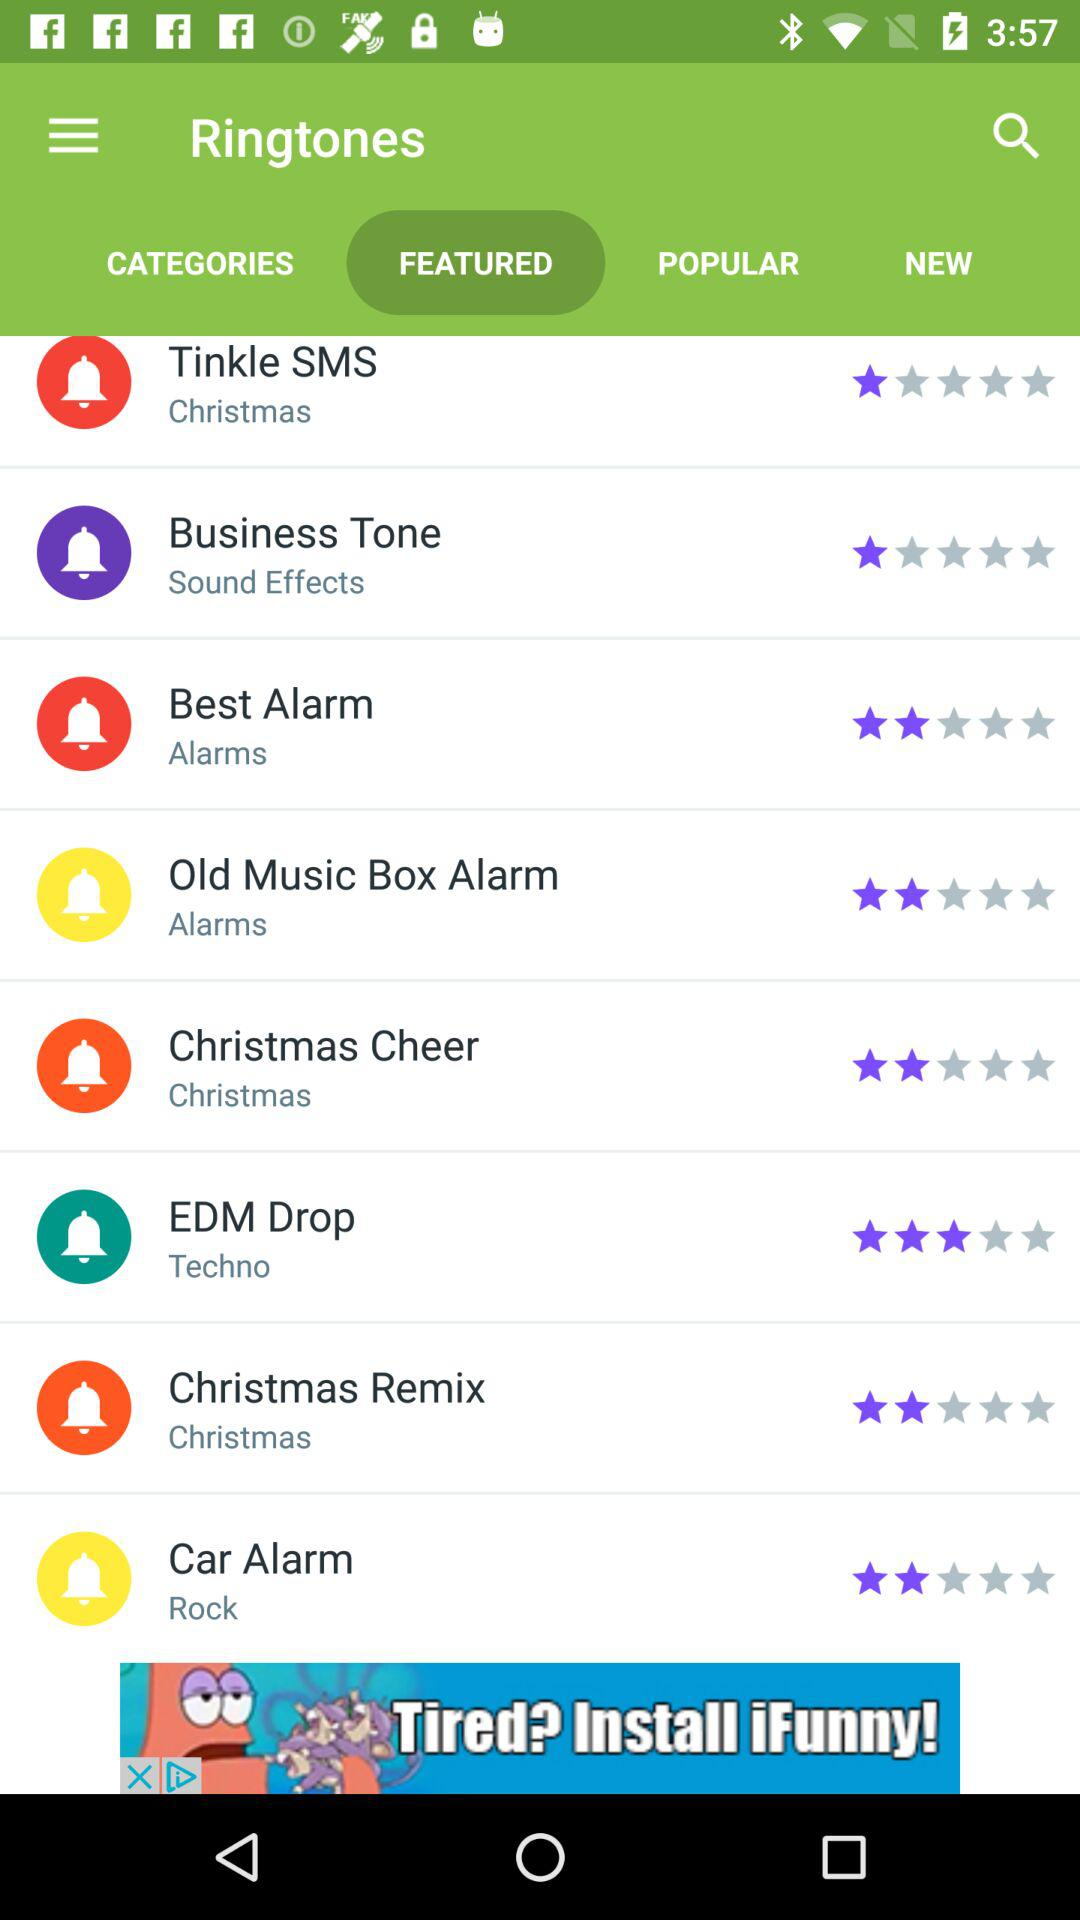How many stars did "Christmas Remix" get? "Christmas Remix" got 2 stars. 